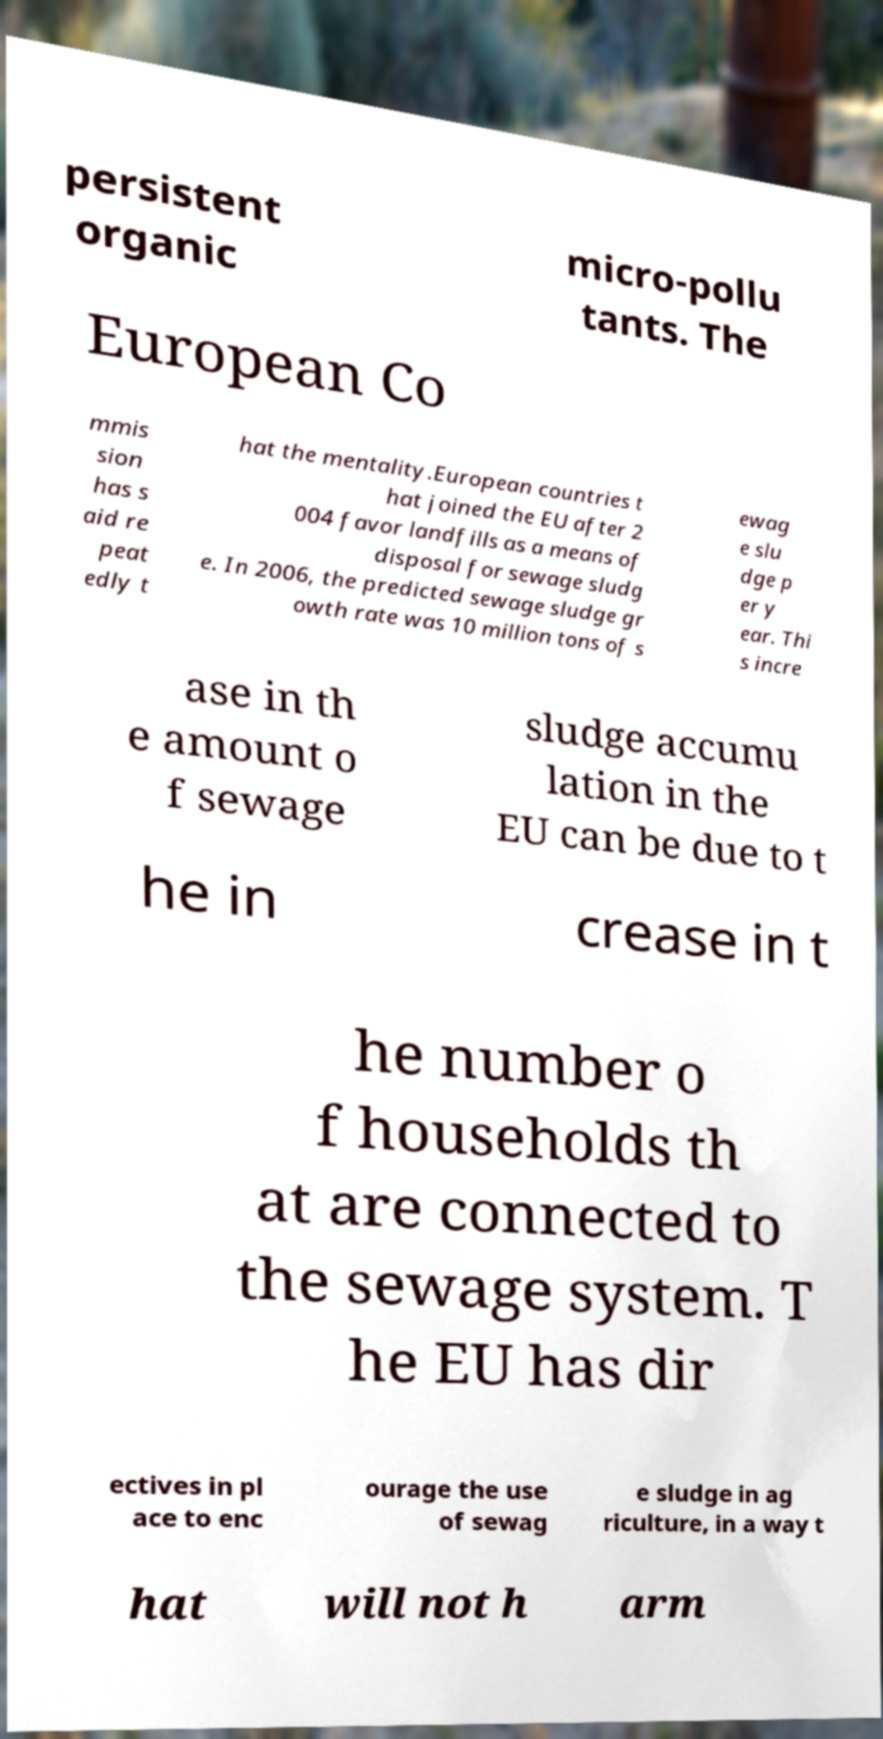Can you read and provide the text displayed in the image?This photo seems to have some interesting text. Can you extract and type it out for me? persistent organic micro-pollu tants. The European Co mmis sion has s aid re peat edly t hat the mentality.European countries t hat joined the EU after 2 004 favor landfills as a means of disposal for sewage sludg e. In 2006, the predicted sewage sludge gr owth rate was 10 million tons of s ewag e slu dge p er y ear. Thi s incre ase in th e amount o f sewage sludge accumu lation in the EU can be due to t he in crease in t he number o f households th at are connected to the sewage system. T he EU has dir ectives in pl ace to enc ourage the use of sewag e sludge in ag riculture, in a way t hat will not h arm 